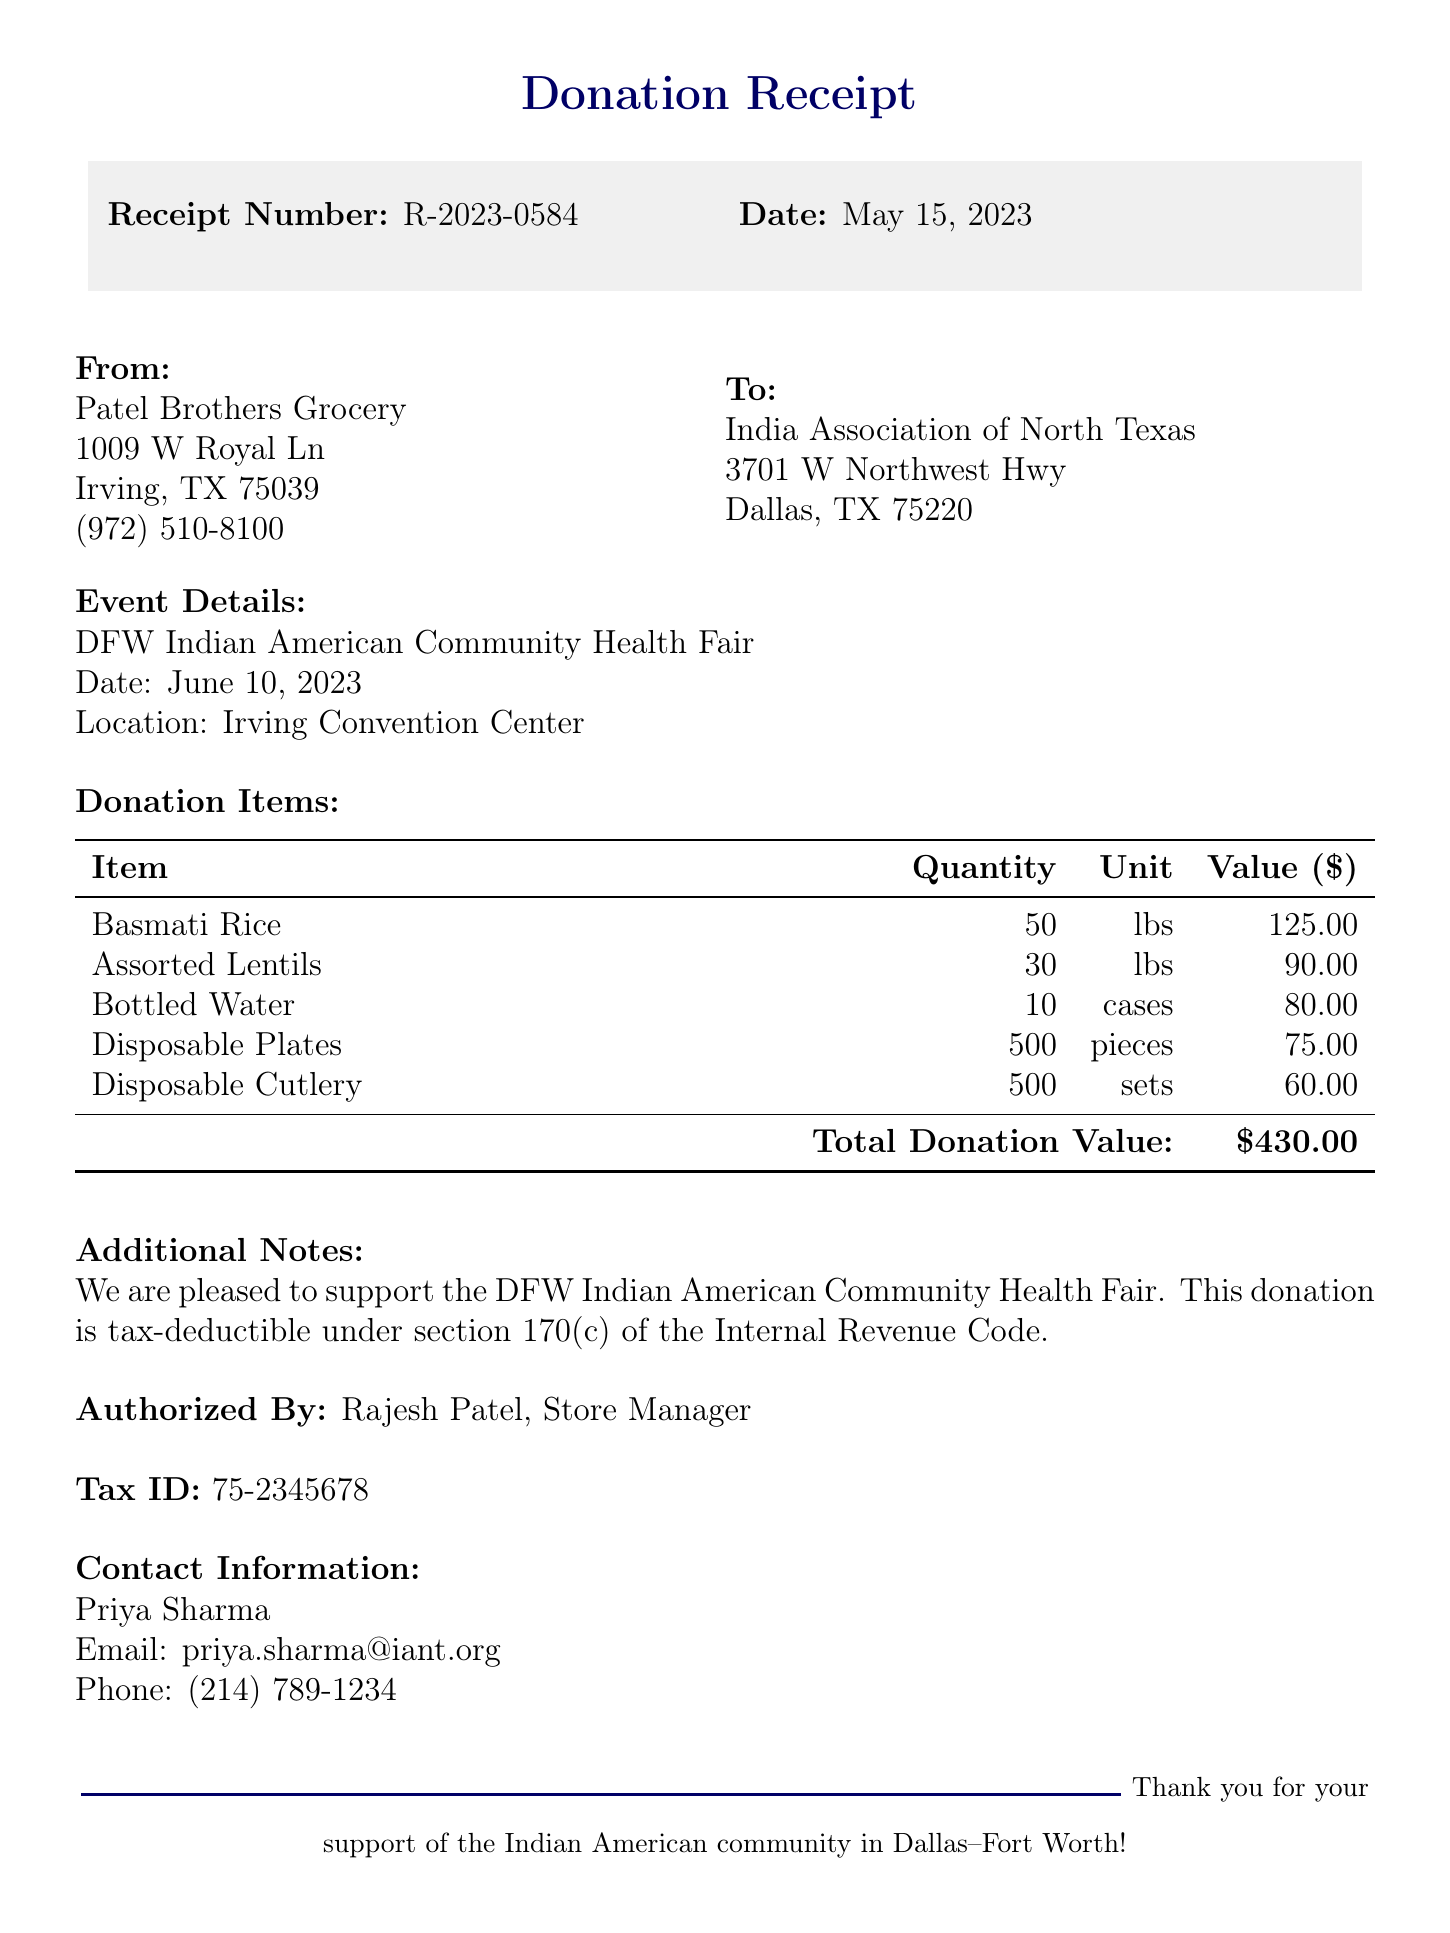What is the receipt number? The receipt number is listed at the top of the document as R-2023-0584.
Answer: R-2023-0584 What is the date of the donation? The date of the donation is mentioned in the document as May 15, 2023.
Answer: May 15, 2023 Who is the authorized person for this donation? The document notes that the authorized person for the donation is Rajesh Patel, identified as the Store Manager.
Answer: Rajesh Patel What is the total donation value? The total donation value is calculated and presented at the end of the donation items section as $430.00.
Answer: $430.00 What items were donated? The document lists multiple items that were donated, including Basmati Rice and Assorted Lentils.
Answer: Basmati Rice, Assorted Lentils, Bottled Water, Disposable Plates, Disposable Cutlery What is the tax ID of the store? The tax ID is provided in the document and is noted as 75-2345678.
Answer: 75-2345678 When is the community health fair taking place? The document states that the community health fair is scheduled for June 10, 2023.
Answer: June 10, 2023 Where is the event location? The event location is specified in the document as the Irving Convention Center.
Answer: Irving Convention Center Who should be contacted for more information? The contact person mentioned in the document for further information is Priya Sharma.
Answer: Priya Sharma 